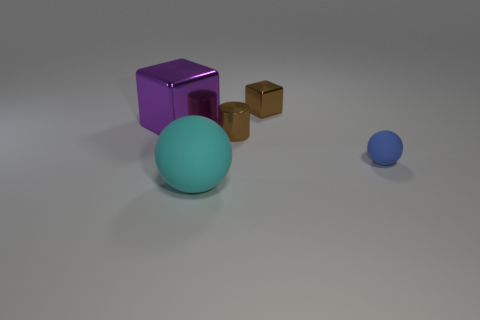Is the material of the ball that is right of the big cyan matte sphere the same as the large purple block?
Provide a short and direct response. No. Are there more small things that are behind the big cyan object than large purple metal blocks that are in front of the big purple thing?
Provide a succinct answer. Yes. What material is the cube that is the same size as the blue rubber ball?
Your response must be concise. Metal. What number of other things are made of the same material as the cyan thing?
Offer a very short reply. 1. Is the shape of the small blue matte thing on the right side of the cyan sphere the same as the rubber thing that is in front of the small blue thing?
Make the answer very short. Yes. What number of other objects are the same color as the big ball?
Keep it short and to the point. 0. Is the large object that is in front of the large block made of the same material as the thing behind the big purple cube?
Offer a very short reply. No. Is the number of large metal blocks in front of the blue thing the same as the number of objects left of the purple shiny object?
Keep it short and to the point. Yes. What material is the big thing that is in front of the blue ball?
Provide a succinct answer. Rubber. Is there anything else that is the same size as the cyan rubber sphere?
Offer a very short reply. Yes. 